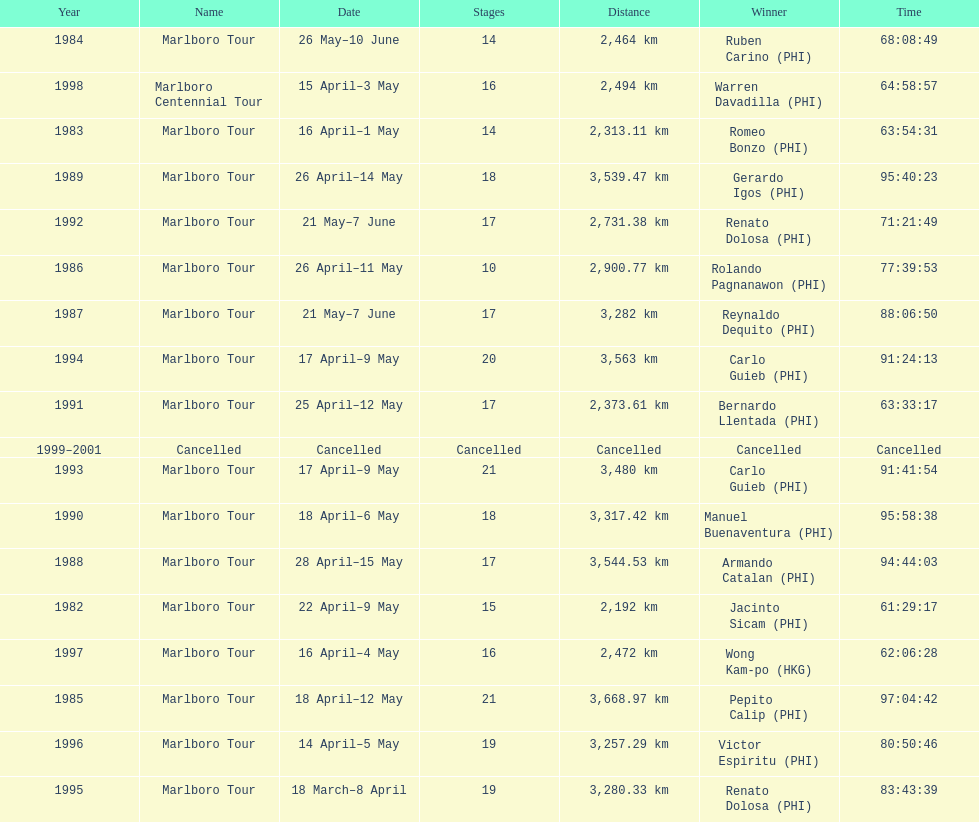Who was the only winner to have their time below 61:45:00? Jacinto Sicam. 